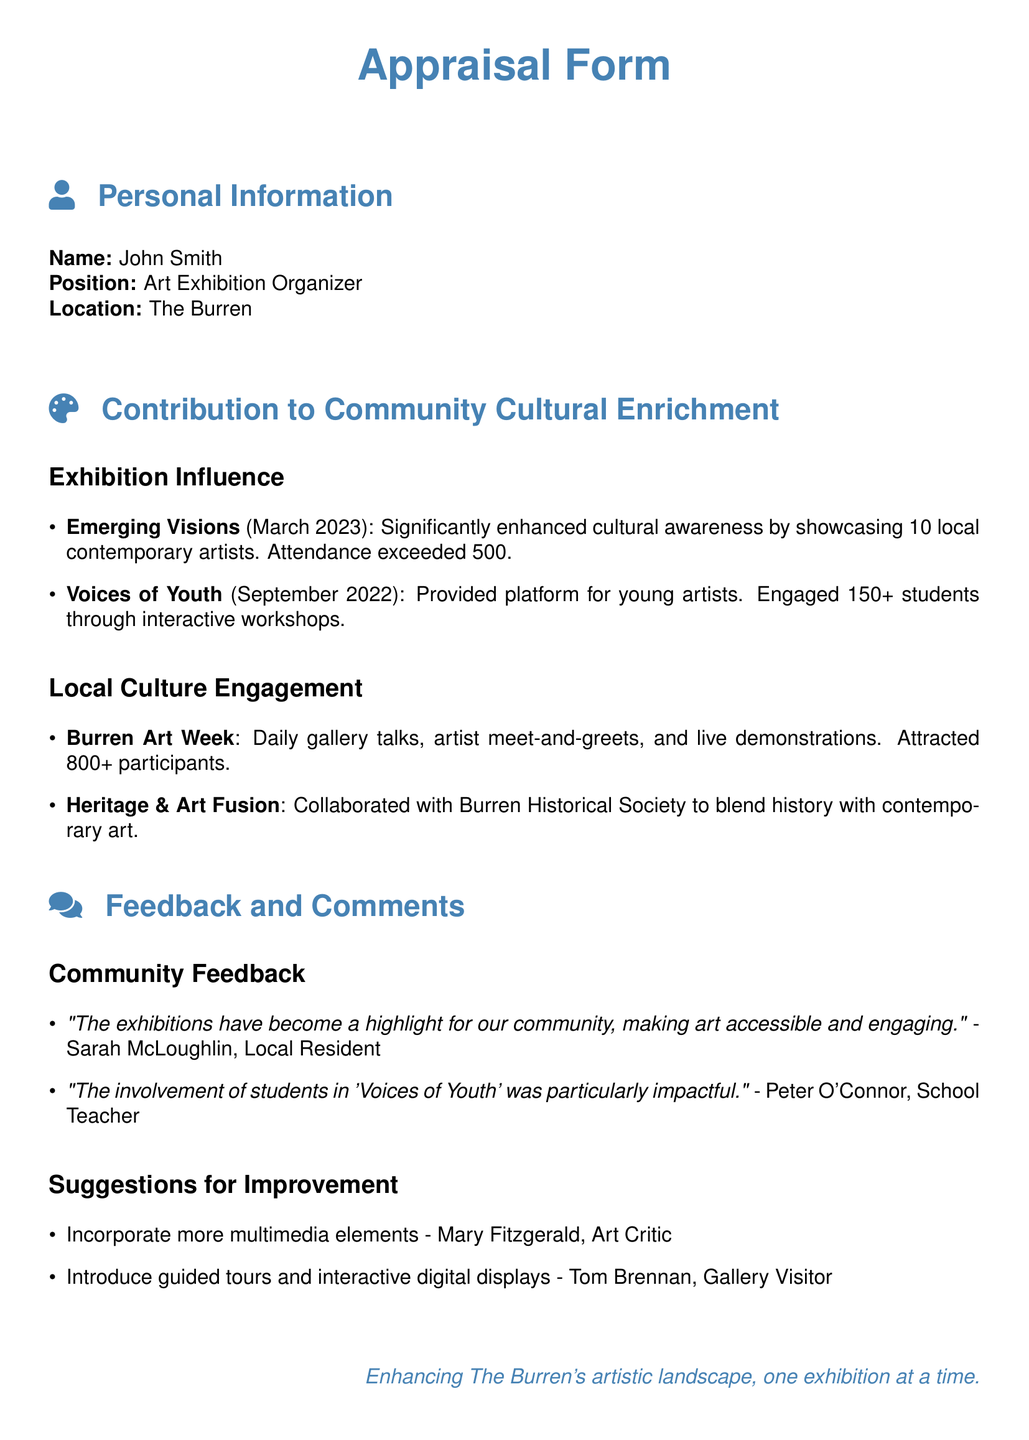What was the attendance for the "Emerging Visions" exhibition? The attendance is a specific number mentioned in the document, which indicates the success of the exhibition.
Answer: 500 How many students were engaged in the "Voices of Youth" exhibition? This information outlines the level of community involvement, particularly among young people.
Answer: 150+ What type of collaboration is mentioned in the document? The collaboration illustrates efforts to integrate different facets of local culture with contemporary art.
Answer: Burren Historical Society What was the primary focus of "Voices of Youth"? Understanding the focus of the exhibition helps clarify its goals and target audience.
Answer: Platform for young artists How many participants attended the Burren Art Week? This number reflects the community engagement and interest in the event.
Answer: 800+ What feedback was given by Sarah McLoughlin? This feedback demonstrates the community's perception and value of the exhibitions.
Answer: "The exhibitions have become a highlight for our community, making art accessible and engaging." What suggestion was made by Mary Fitzgerald? This suggestion offers insight into potential areas for improving future exhibitions.
Answer: Incorporate more multimedia elements What was a feature of the Burren Art Week? Identifying specific features helps understand what activities attracted participation.
Answer: Daily gallery talks 